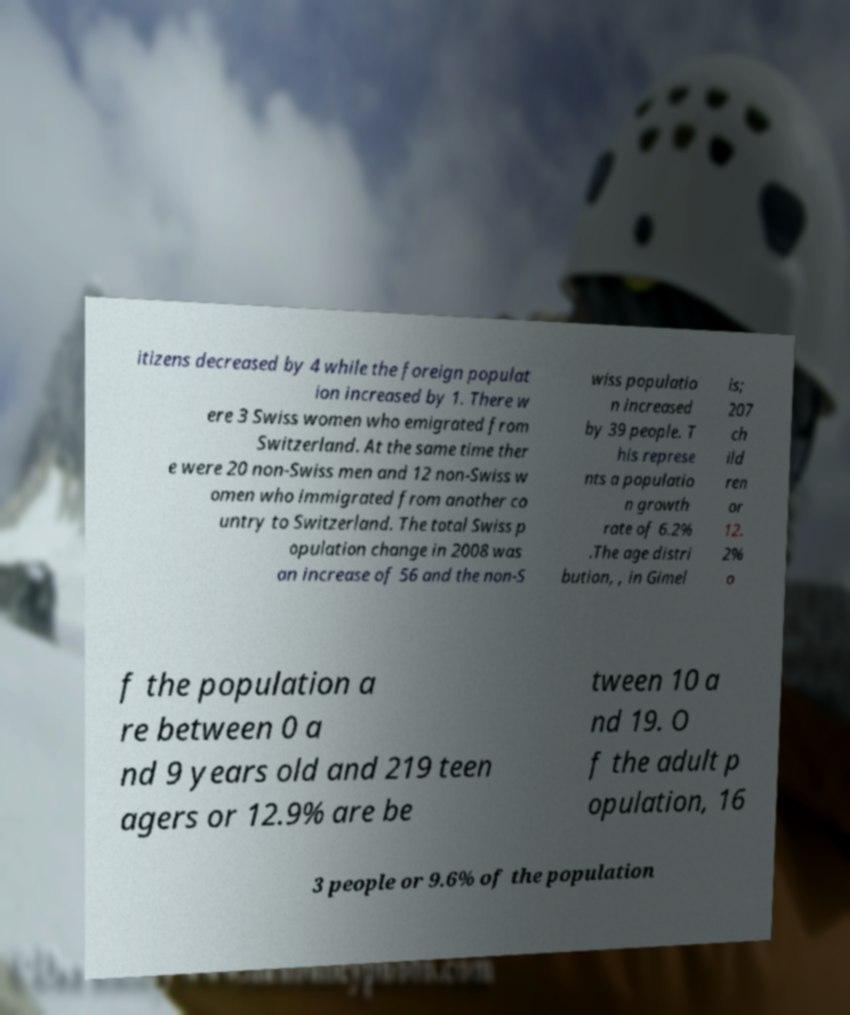There's text embedded in this image that I need extracted. Can you transcribe it verbatim? itizens decreased by 4 while the foreign populat ion increased by 1. There w ere 3 Swiss women who emigrated from Switzerland. At the same time ther e were 20 non-Swiss men and 12 non-Swiss w omen who immigrated from another co untry to Switzerland. The total Swiss p opulation change in 2008 was an increase of 56 and the non-S wiss populatio n increased by 39 people. T his represe nts a populatio n growth rate of 6.2% .The age distri bution, , in Gimel is; 207 ch ild ren or 12. 2% o f the population a re between 0 a nd 9 years old and 219 teen agers or 12.9% are be tween 10 a nd 19. O f the adult p opulation, 16 3 people or 9.6% of the population 